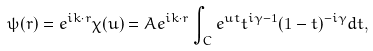<formula> <loc_0><loc_0><loc_500><loc_500>\psi ( { r } ) = { e ^ { i { k \cdot r } } } \chi ( u ) = A { e ^ { i { k \cdot r } } } \int _ { C } { e ^ { u t } } { t ^ { i \gamma - 1 } } ( 1 - t ) ^ { - i \gamma } d t ,</formula> 